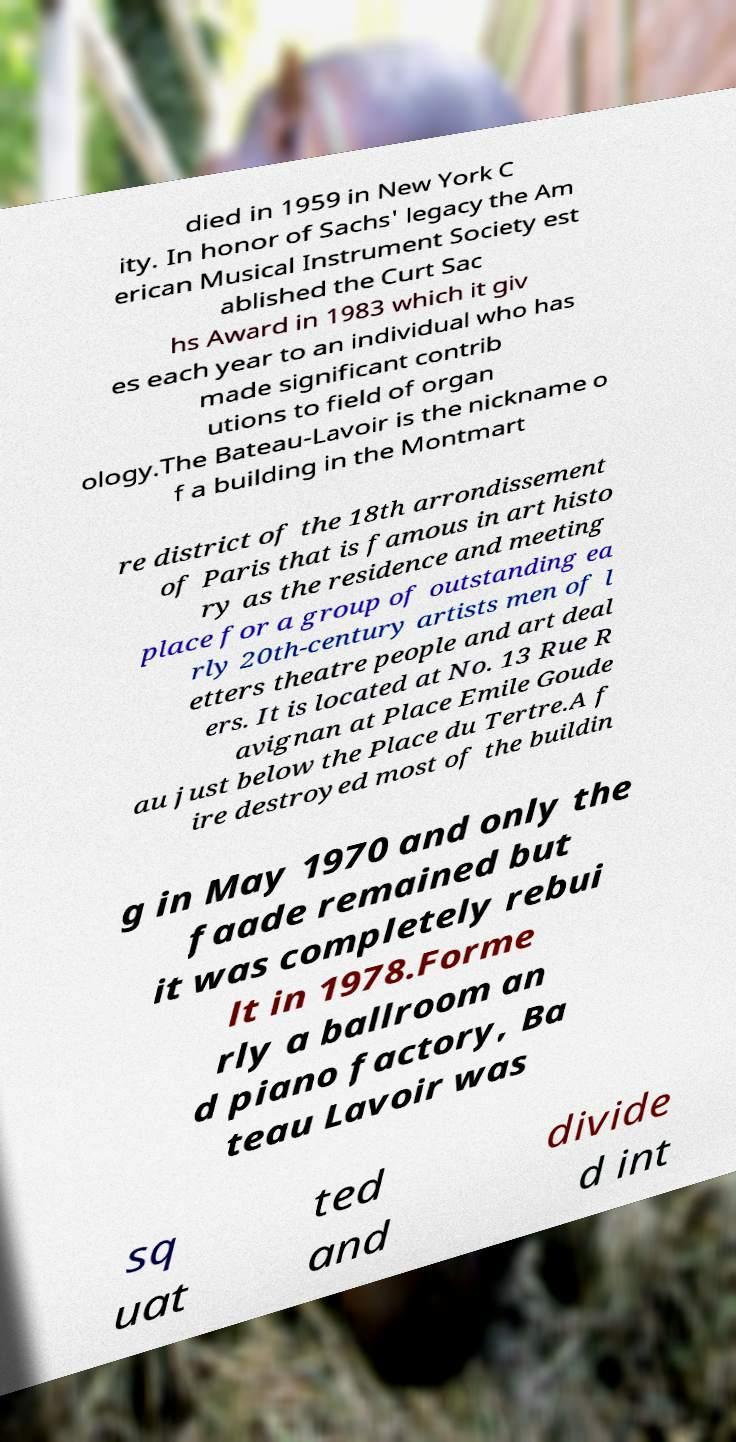For documentation purposes, I need the text within this image transcribed. Could you provide that? died in 1959 in New York C ity. In honor of Sachs' legacy the Am erican Musical Instrument Society est ablished the Curt Sac hs Award in 1983 which it giv es each year to an individual who has made significant contrib utions to field of organ ology.The Bateau-Lavoir is the nickname o f a building in the Montmart re district of the 18th arrondissement of Paris that is famous in art histo ry as the residence and meeting place for a group of outstanding ea rly 20th-century artists men of l etters theatre people and art deal ers. It is located at No. 13 Rue R avignan at Place Emile Goude au just below the Place du Tertre.A f ire destroyed most of the buildin g in May 1970 and only the faade remained but it was completely rebui lt in 1978.Forme rly a ballroom an d piano factory, Ba teau Lavoir was sq uat ted and divide d int 